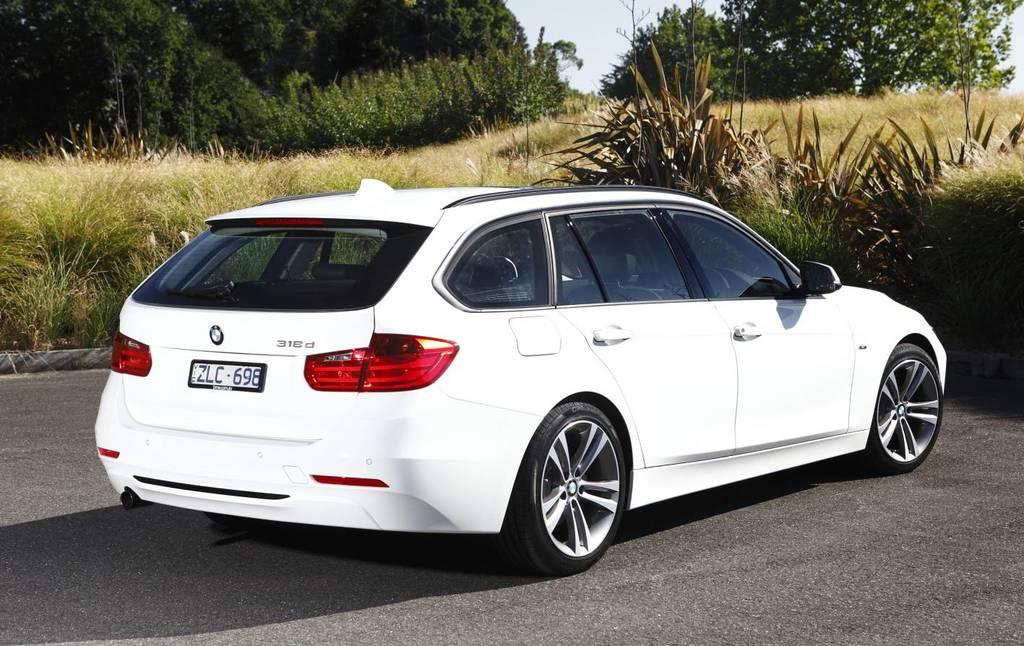<image>
Relay a brief, clear account of the picture shown. A white BMW 316d with the license plate ZLC-698 